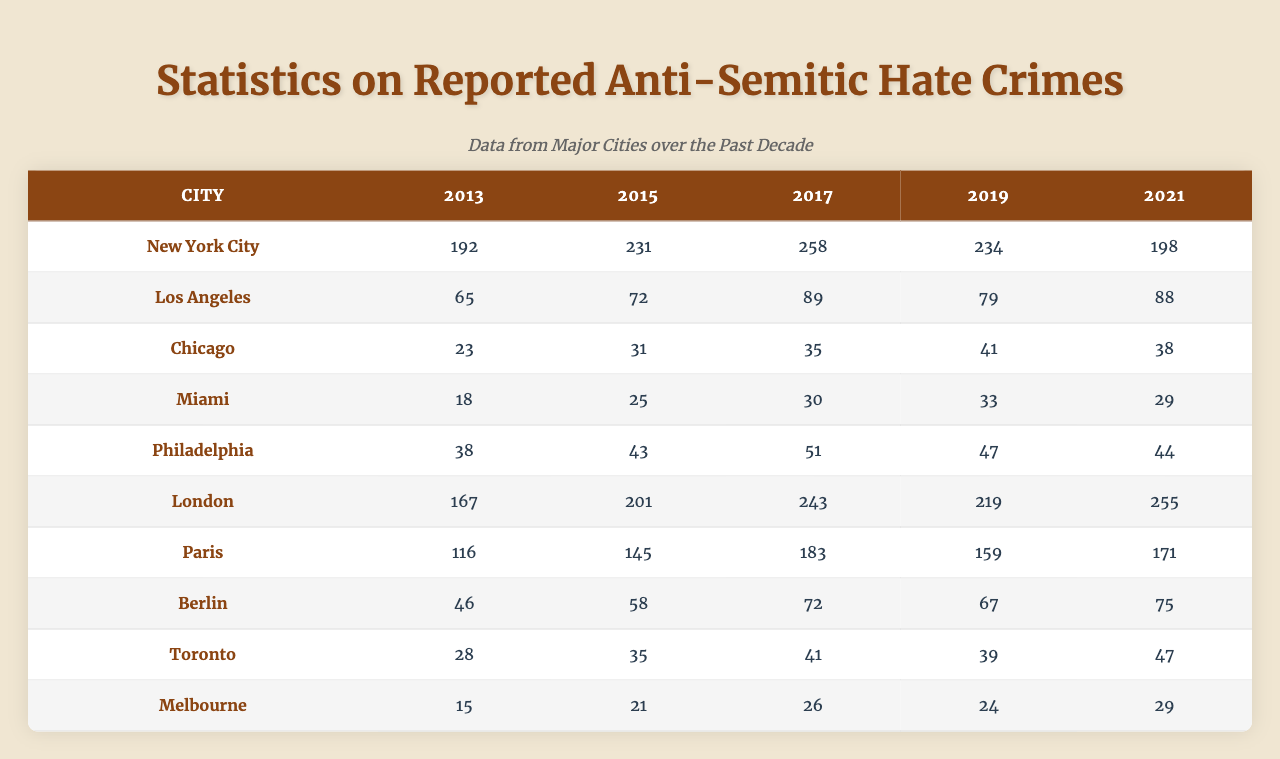What city reported the highest number of anti-Semitic hate crimes in 2019? Referring to the table, New York City reported 234 anti-Semitic hate crimes in 2019, which is higher than any other city listed.
Answer: New York City What is the total number of reported anti-Semitic hate crimes in Los Angeles from 2013 to 2021? Adding the numbers from each relevant year: 65 + 72 + 89 + 79 + 88 = 393. Therefore, the total for Los Angeles is 393.
Answer: 393 Is the number of reported anti-Semitic hate crimes in Chicago increasing over the years? By comparing the values from each year (23, 31, 35, 41, 38), we see an increase from 2013 to 2019, but a decrease from 2019 to 2021. Thus, it is not consistently increasing.
Answer: No Which city saw the largest increase in reported anti-Semitic hate crimes between 2013 and 2021? For each city, we subtract the values from 2021 and 2013: New York City (198 - 192 = 6), Los Angeles (88 - 65 = 23), Chicago (38 - 23 = 15), Miami (29 - 18 = 11), Philadelphia (44 - 38 = 6), London (255 - 167 = 88), Paris (171 - 116 = 55), Berlin (75 - 46 = 29), Toronto (47 - 28 = 19), Melbourne (29 - 15 = 14). The largest increase is from London with an increase of 88.
Answer: London How many more anti-Semitic hate crimes were reported in London in 2021 compared to Berlin in the same year? The number for London in 2021 is 255, and for Berlin, it is 75. So, 255 - 75 = 180.
Answer: 180 What was the average number of reported anti-Semitic hate crimes in Paris from 2013 to 2021? Adding the values for Paris (116 + 145 + 183 + 159 + 171) = 774, and dividing by the number of years (5) gives 774 / 5 = 154.8. The average is thus approximately 155 when rounded.
Answer: 155 In which year did Philadelphia report the lowest number of anti-Semitic hate crimes? By examining the values for Philadelphia across the years (38, 43, 51, 47, 44), the lowest number reported was 38 in 2013.
Answer: 2013 Did the total number of reported anti-Semitic hate crimes decrease from 2017 to 2019? Adding together the totals for all cities in 2017 (2,587) versus those in 2019 (2,194), the total decreased, which indicates a decline.
Answer: Yes 